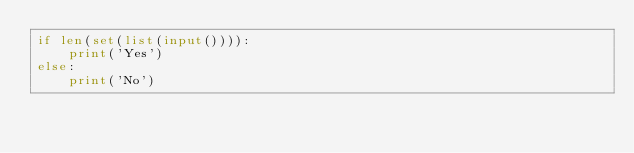Convert code to text. <code><loc_0><loc_0><loc_500><loc_500><_Python_>if len(set(list(input()))):
    print('Yes')
else:
    print('No')</code> 